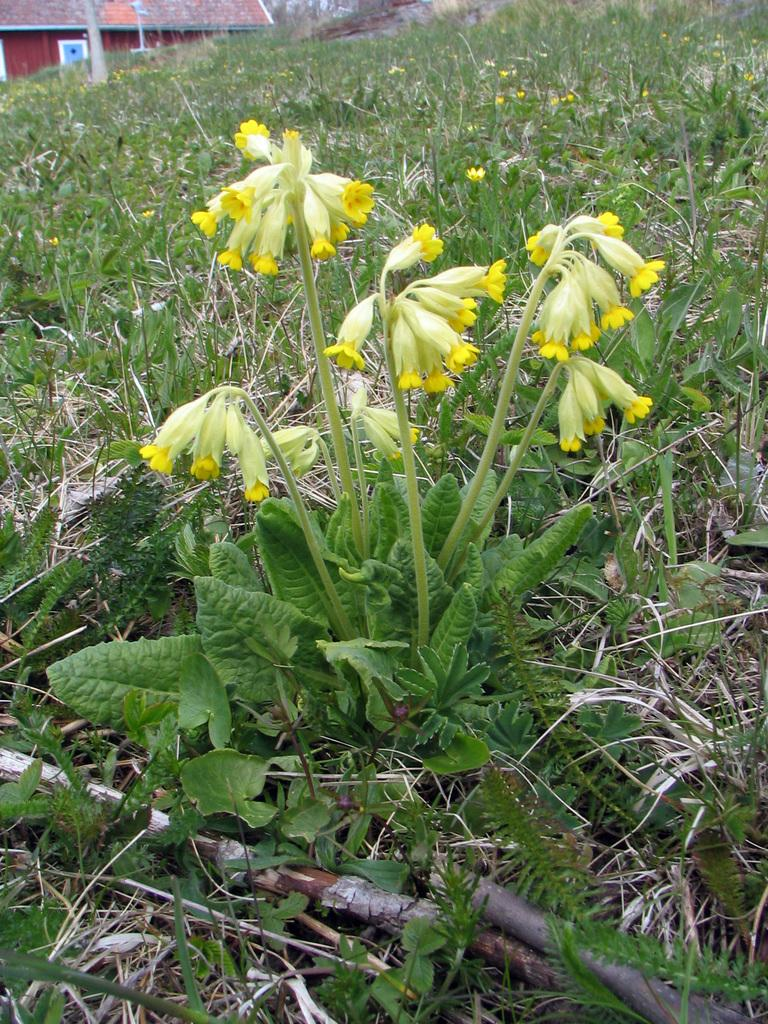What type of environment is depicted in the image? The image features greenery, suggesting a natural or outdoor setting. Can you describe the structure located at the top side of the image? There is a house at the top side of the image. What type of music can be heard coming from the branch in the image? There is no branch or music present in the image. 